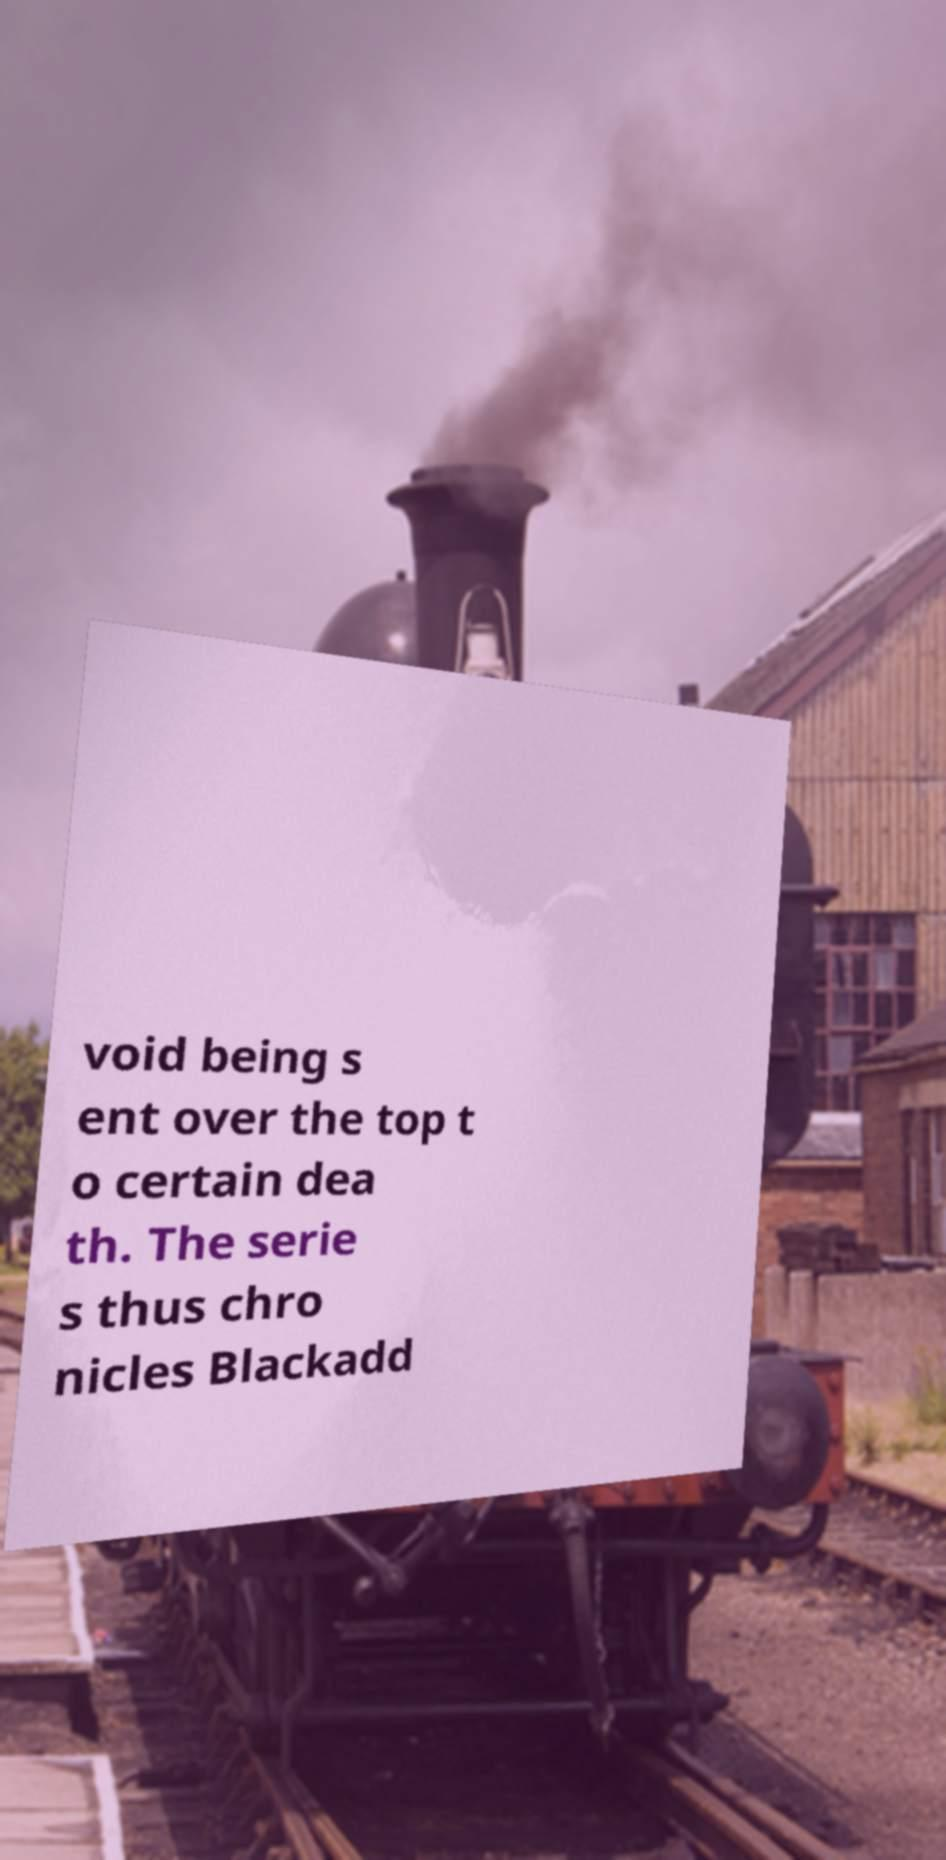I need the written content from this picture converted into text. Can you do that? void being s ent over the top t o certain dea th. The serie s thus chro nicles Blackadd 